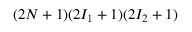Convert formula to latex. <formula><loc_0><loc_0><loc_500><loc_500>( 2 N + 1 ) ( 2 I _ { 1 } + 1 ) ( 2 I _ { 2 } + 1 )</formula> 